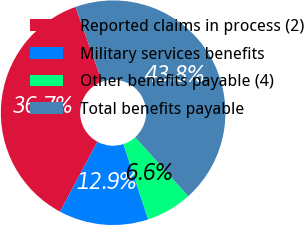Convert chart. <chart><loc_0><loc_0><loc_500><loc_500><pie_chart><fcel>Reported claims in process (2)<fcel>Military services benefits<fcel>Other benefits payable (4)<fcel>Total benefits payable<nl><fcel>36.71%<fcel>12.9%<fcel>6.61%<fcel>43.78%<nl></chart> 